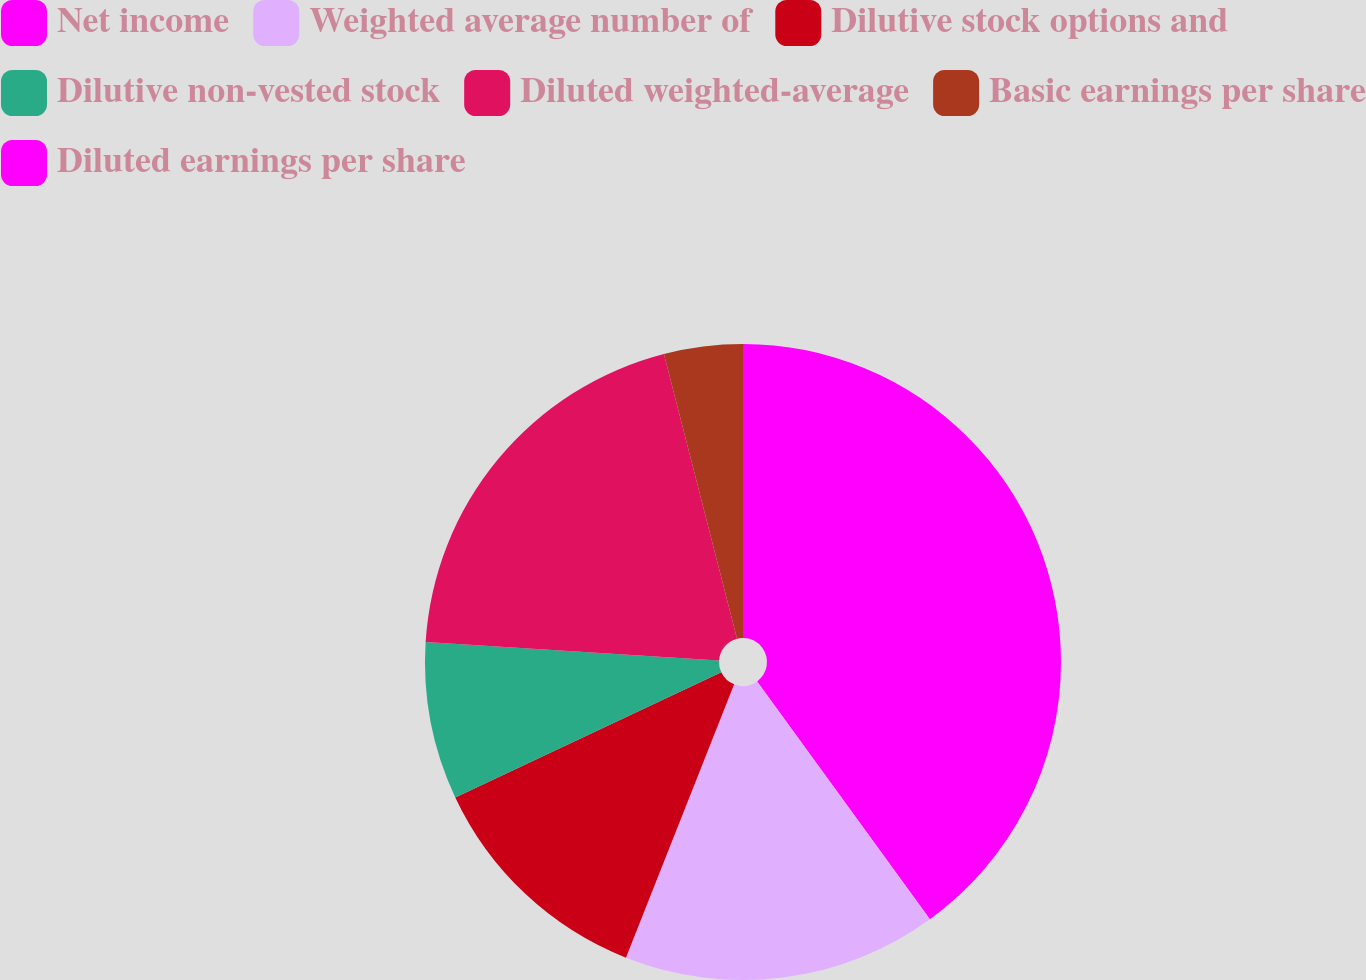Convert chart to OTSL. <chart><loc_0><loc_0><loc_500><loc_500><pie_chart><fcel>Net income<fcel>Weighted average number of<fcel>Dilutive stock options and<fcel>Dilutive non-vested stock<fcel>Diluted weighted-average<fcel>Basic earnings per share<fcel>Diluted earnings per share<nl><fcel>40.0%<fcel>16.0%<fcel>12.0%<fcel>8.0%<fcel>20.0%<fcel>4.0%<fcel>0.0%<nl></chart> 